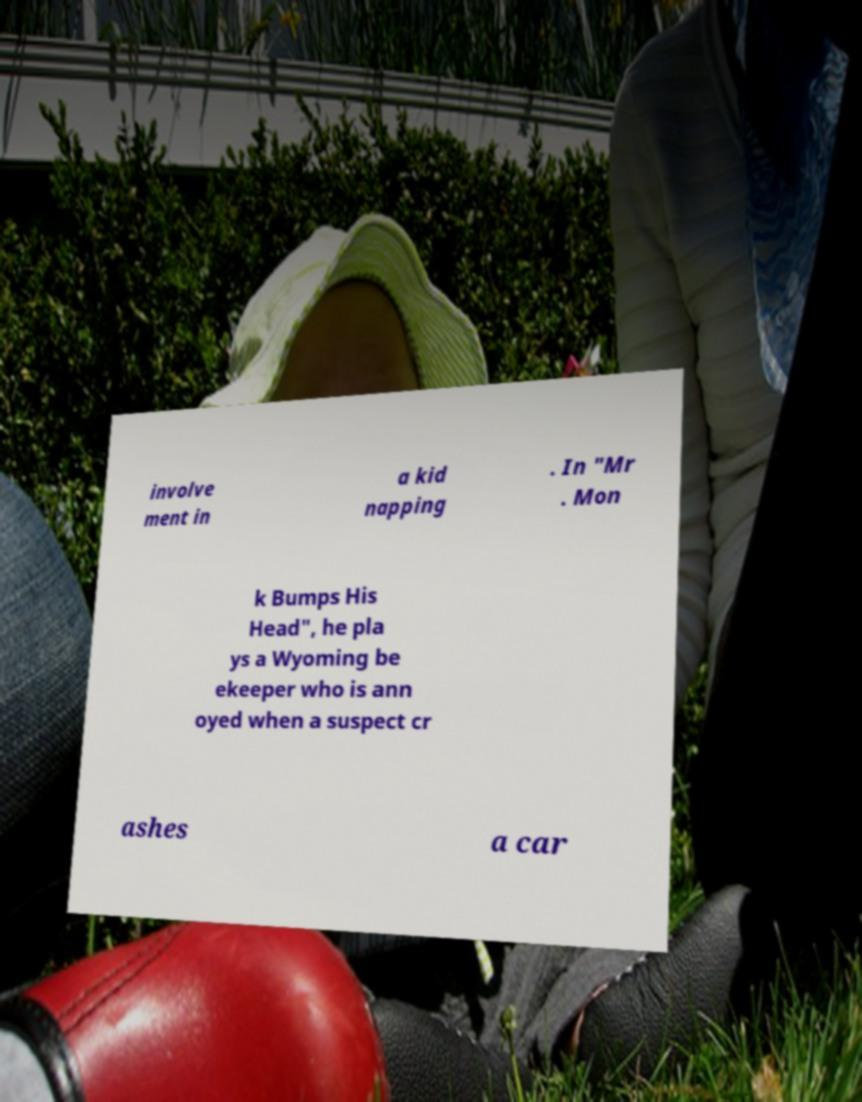What messages or text are displayed in this image? I need them in a readable, typed format. involve ment in a kid napping . In "Mr . Mon k Bumps His Head", he pla ys a Wyoming be ekeeper who is ann oyed when a suspect cr ashes a car 